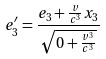<formula> <loc_0><loc_0><loc_500><loc_500>e _ { 3 } ^ { \prime } = \frac { e _ { 3 } + \frac { v } { c ^ { 3 } } x _ { 3 } } { \sqrt { 0 + \frac { v ^ { 3 } } { c ^ { 3 } } } }</formula> 